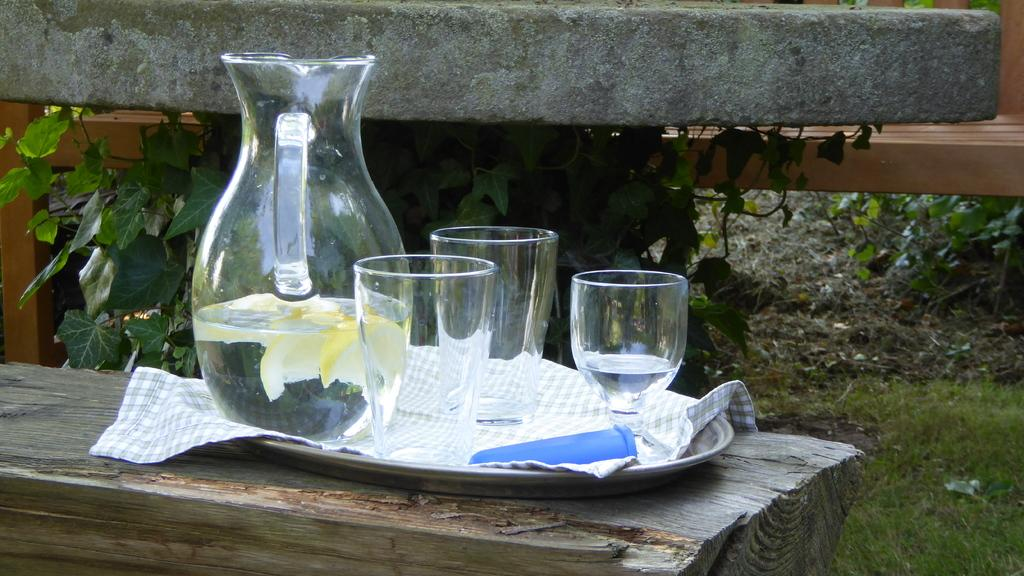What is the main object in the image? There is a water jar in the image. What else can be seen with the water jar? There are glasses with the tray in the image. Where is the tray placed? The tray is placed on a tree trunk. What can be seen in the background of the image? There is a wooden bench and a small plant with leaves in the background of the image. How many stamps are on the water jar in the image? There are no stamps present on the water jar or in the image. Can you see a kiss being exchanged between two people in the image? There is no kiss being exchanged between two people in the image. 